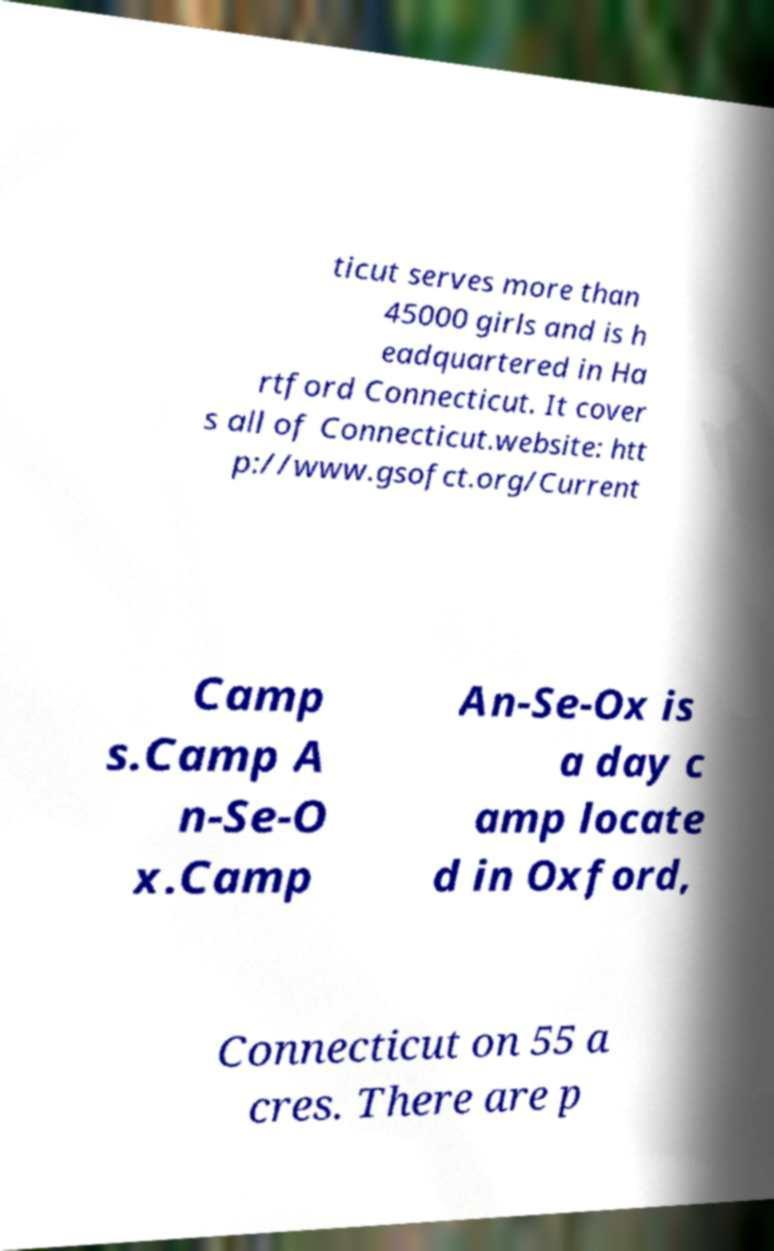Please read and relay the text visible in this image. What does it say? ticut serves more than 45000 girls and is h eadquartered in Ha rtford Connecticut. It cover s all of Connecticut.website: htt p://www.gsofct.org/Current Camp s.Camp A n-Se-O x.Camp An-Se-Ox is a day c amp locate d in Oxford, Connecticut on 55 a cres. There are p 